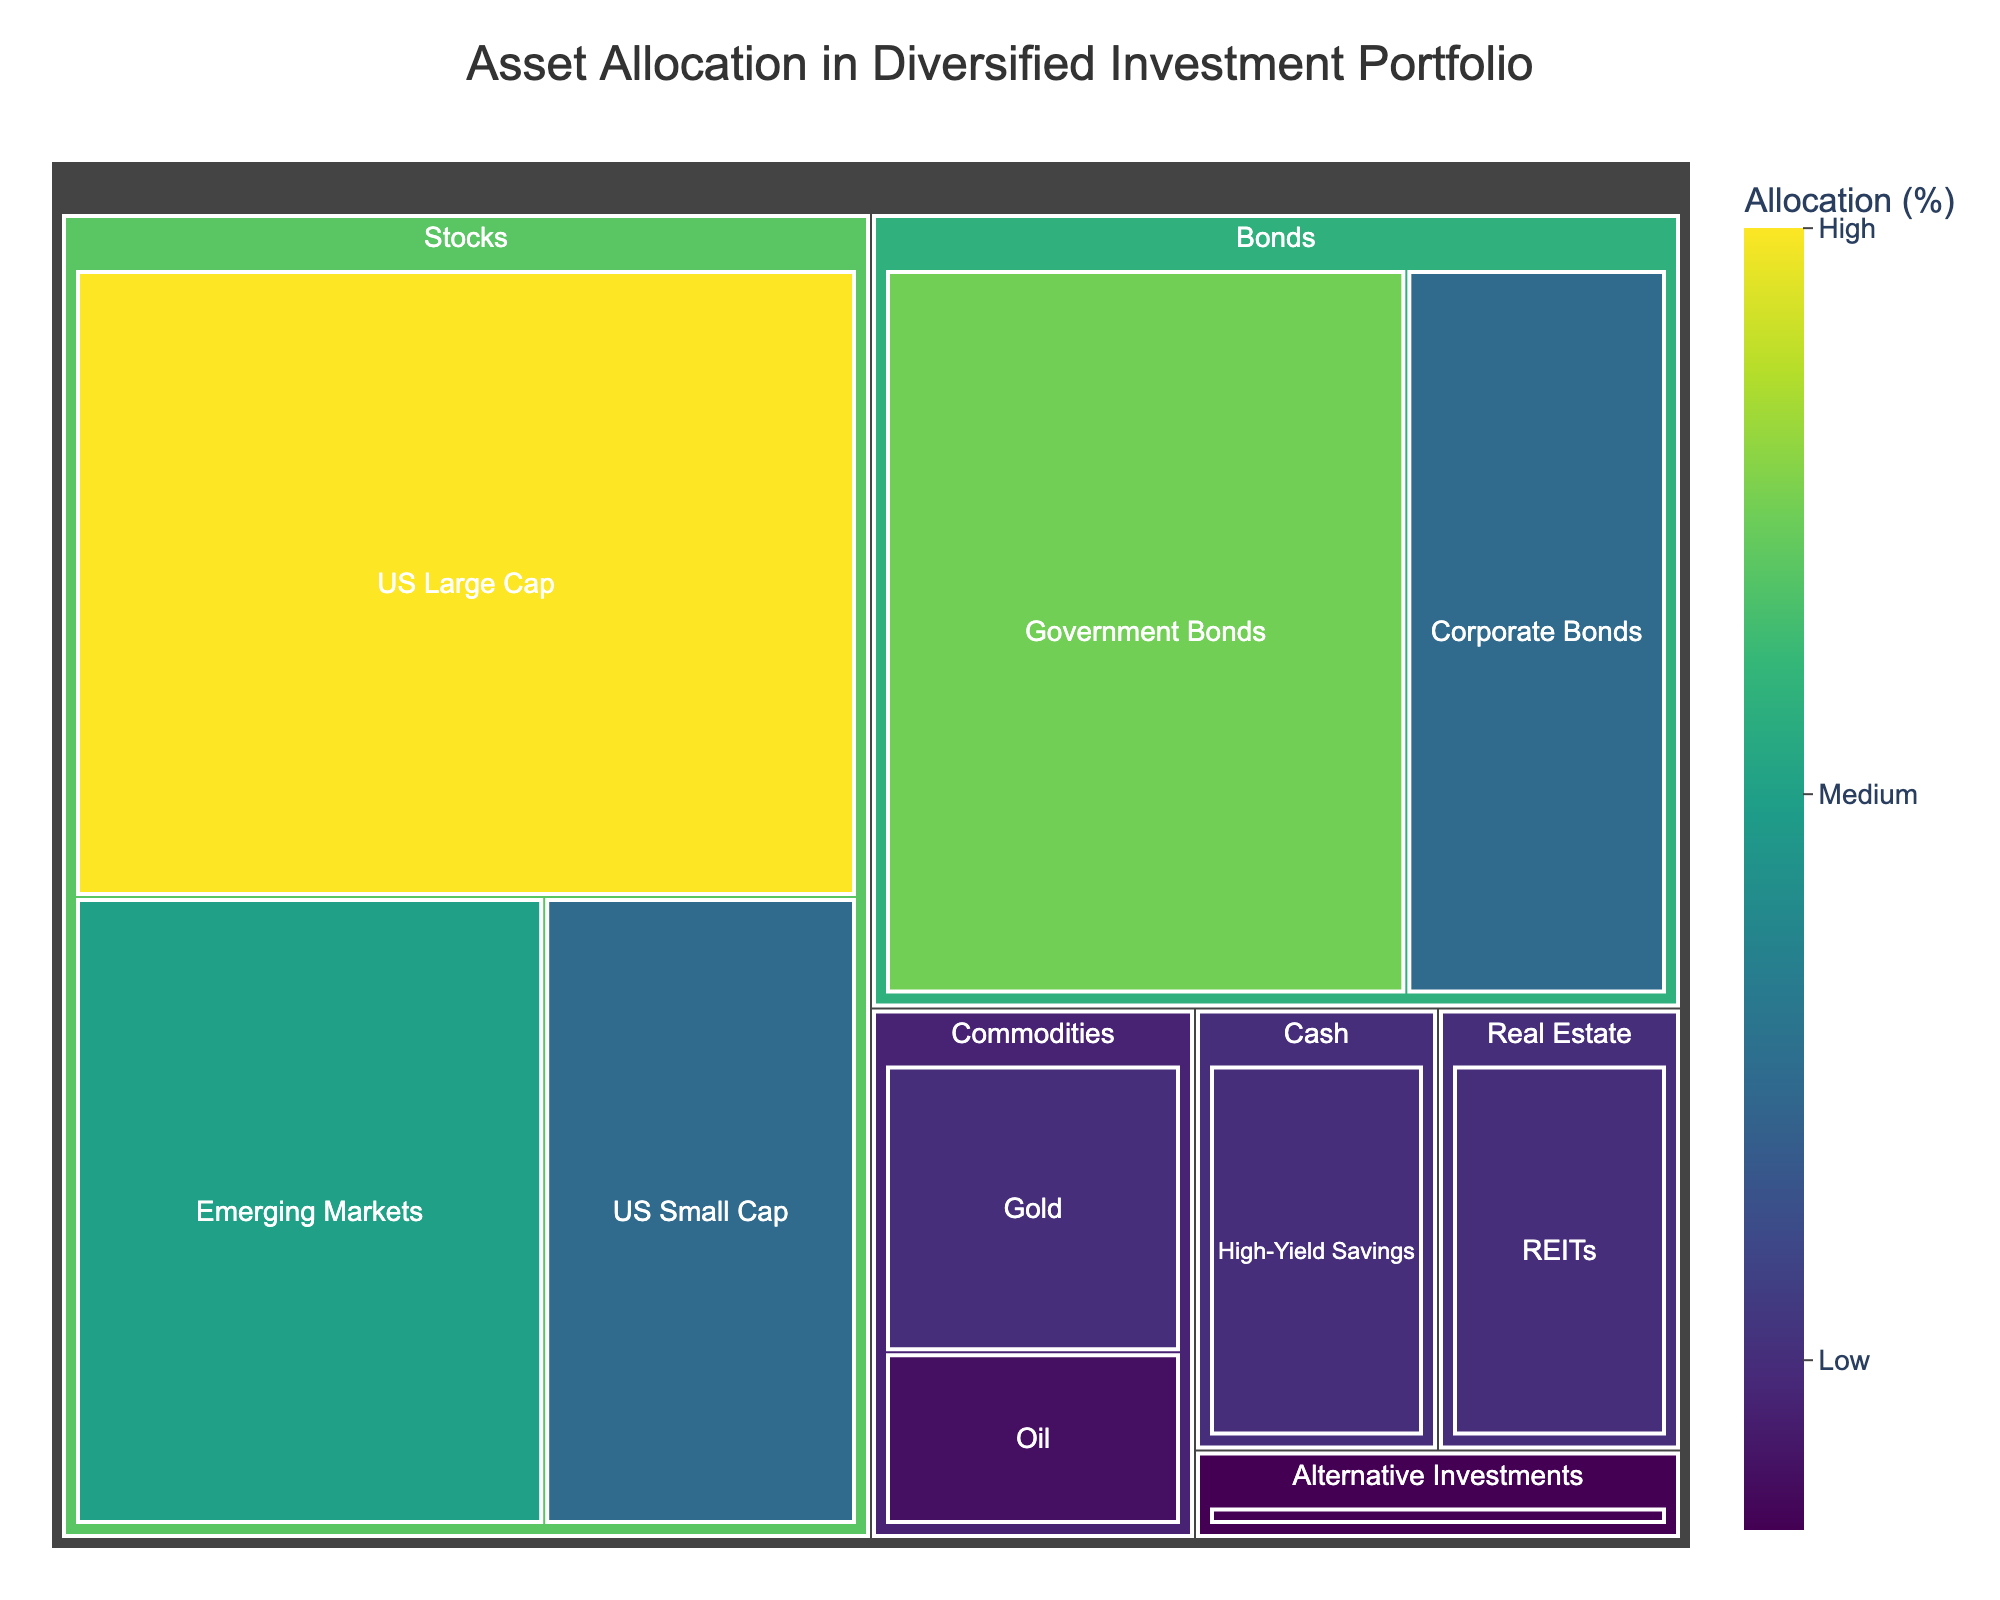what is the title of the treemap? The title is clearly displayed at the top of the figure. It reads: "Asset Allocation in Diversified Investment Portfolio."
Answer: Asset Allocation in a Diversified Investment Portfolio Which category has the highest allocation? The "Stocks" category has the largest area in the treemap, indicating it has the highest value in the dataset.
Answer: Stocks How much is allocated to "US Large Cap" stocks? By looking at the "US Large Cap" section within the "Stocks" category, we see it is labeled with 25%.
Answer: 25% How does the allocation to “Cash” compare to "Real Estate"? Comparing the areas for "Cash" and "Real Estate" in the treemap, "Cash" has a 5% allocation and "Real Estate" has a 5% allocation as well.
Answer: Both are equal What is the total allocation for the "Commodities" category? "Commodities" consists of "Gold" (5%) and "Oil" (3%). Adding these values gives a total allocation of 5 + 3 = 8%.
Answer: 8% What are the subcategories within the "Bonds" category? The "Bonds" category includes "Government Bonds" and "Corporate Bonds."
Answer: Government Bonds, Corporate Bonds Which subcategory within "Stocks" has the second highest allocation? The "US Large Cap" has the highest allocation (25%). The next largest within "Stocks" is "Emerging Markets," which has 15%.
Answer: Emerging Markets Calculate the combined allocation for “US Small Cap” and “Emerging Markets.” “US Small Cap” is 10%, and “Emerging Markets” is 15%. Adding these gives 10 + 15 = 25%.
Answer: 25% What is the allocation difference between "Government Bonds" and "Corporate Bonds"? "Government Bonds" have 20%, and "Corporate Bonds" have 10%. The difference is 20 - 10 = 10%.
Answer: 10% Which subcategory has the smallest allocation, and what is its value? Observing the smallest area in the treemap, "Hedge Funds" under "Alternative Investments" has the smallest allocation, with 2%.
Answer: Hedge Funds, 2% 